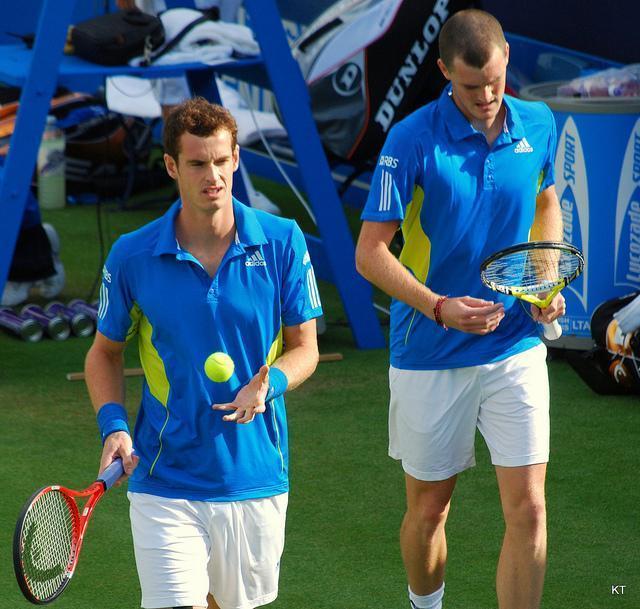How many people are visible?
Give a very brief answer. 2. How many tennis rackets are there?
Give a very brief answer. 2. How many of the dogs are black?
Give a very brief answer. 0. 